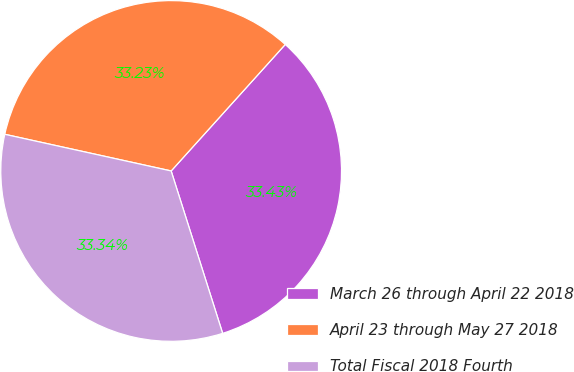<chart> <loc_0><loc_0><loc_500><loc_500><pie_chart><fcel>March 26 through April 22 2018<fcel>April 23 through May 27 2018<fcel>Total Fiscal 2018 Fourth<nl><fcel>33.43%<fcel>33.23%<fcel>33.34%<nl></chart> 